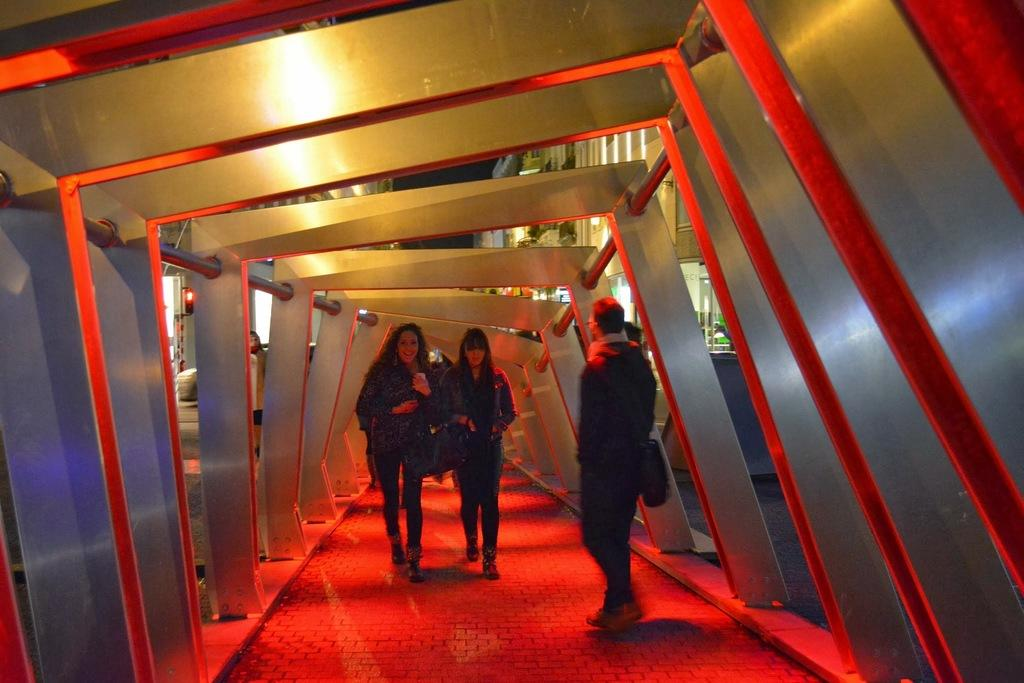How many people are in the image? There are people in the image, but the exact number is not specified. What is the position of the metal rods in relation to the people? There are metal rods on both sides of the people. Can you describe the background of the image? In the background of the image, there is a person, a vehicle, buildings, and the sky. What type of vehicle can be seen in the background? The type of vehicle is not specified in the provided facts. What is the color of the sky in the image? The color of the sky is not specified in the provided facts. How much did the beggar increase the amount of donations in the image? There is no mention of a beggar or donations in the provided facts, so this question cannot be answered. 